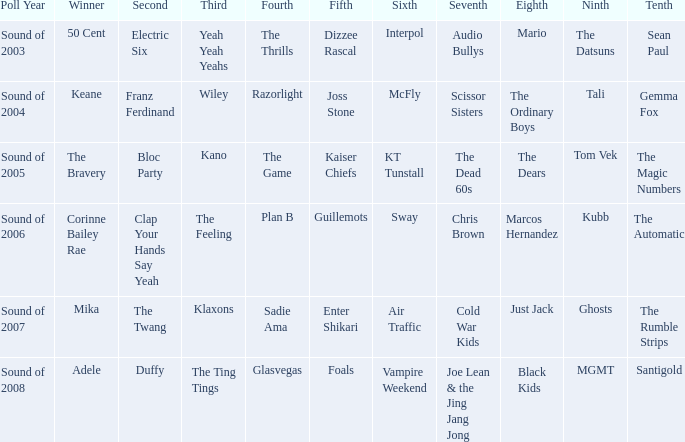Who occupies the 10th position when kubb is in the 9th place? The Automatic. 